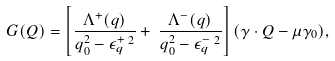Convert formula to latex. <formula><loc_0><loc_0><loc_500><loc_500>G ( Q ) = \left [ \frac { \Lambda ^ { + } ( { q } ) } { q _ { 0 } ^ { 2 } - \epsilon ^ { + } _ { q } \, ^ { 2 } } + \, \frac { \Lambda ^ { - } ( { q } ) } { q _ { 0 } ^ { 2 } - \epsilon ^ { - } _ { q } \, ^ { 2 } } \right ] ( \gamma \cdot Q - \mu \gamma _ { 0 } ) ,</formula> 